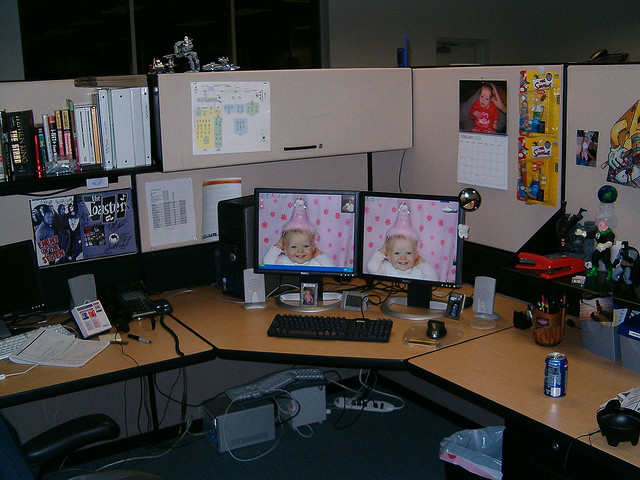<image>What objects are black and white striped in the background? There are no black and white striped objects in the background for me to identify. It could be a calendar, monitor, windows, lists, wall or pictures. The picture on the far right of the cubicle is meant to represent which famous artist's work? I don't know. It may represent the works of Picasso, Matt Groening, Van Gogh or others. What objects are black and white striped in the background? I don't know what objects are black and white striped in the background. It can be seen 'calendar', 'monitor', 'windows', 'wall' or 'pictures'. The picture on the far right of the cubicle is meant to represent which famous artist's work? I don't know which famous artist's work is represented by the picture on the far right of the cubicle. It can be seen as Picasso, Matt Groening, Escher, Van Gogh, or Mozart. 